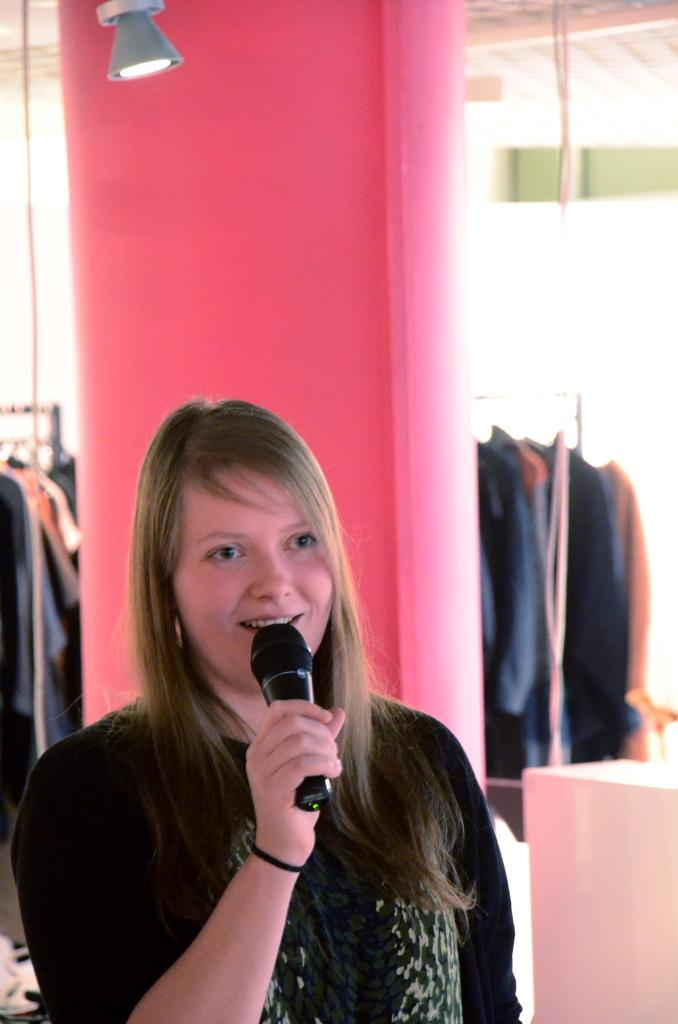Who is the main subject in the image? There is a girl in the image. What is the girl wearing? The girl is wearing a black t-shirt. What is the girl holding in the image? The girl is holding a microphone. Can you describe any other objects or colors in the image? There is a pink color pillar and a lamp in the image. Where is the baby sitting in the image? There is no baby present in the image. What type of party is happening in the image? There is no party depicted in the image. 